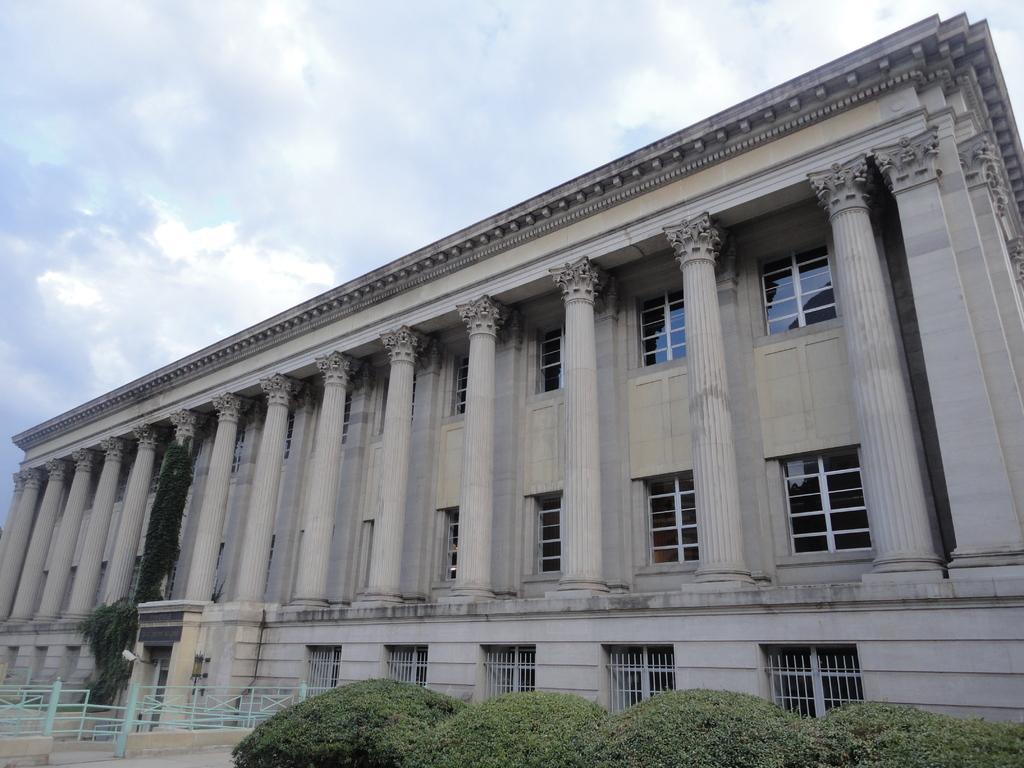Please provide a concise description of this image. This is the picture of a building. In this image there is a building. On the left bottom there is a railing. At the bottom there are plants. At the top there is sky and there are clouds. 